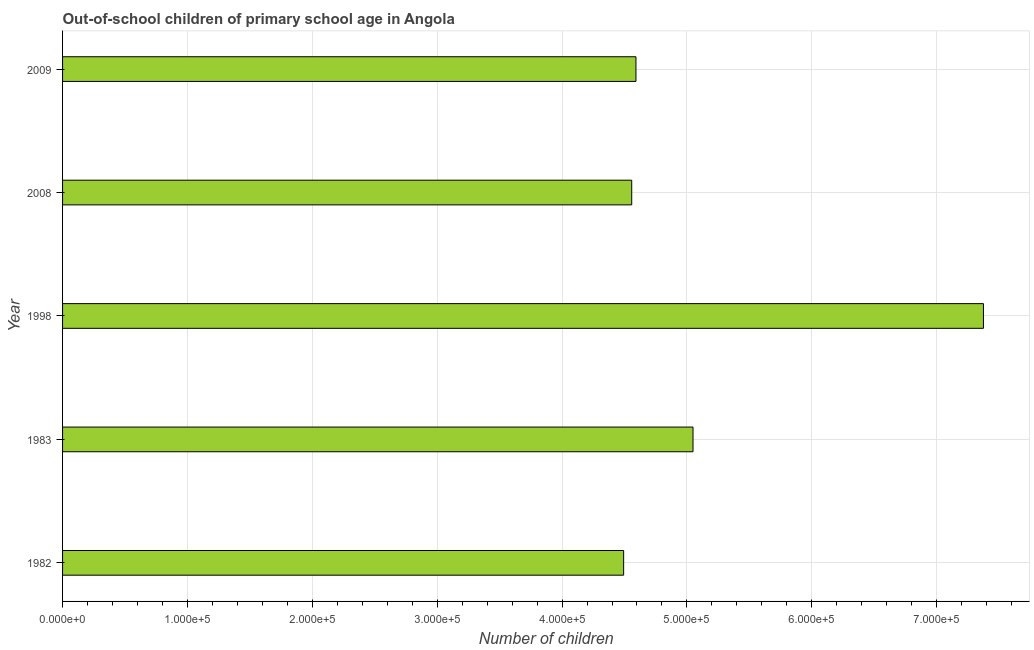Does the graph contain any zero values?
Make the answer very short. No. What is the title of the graph?
Your response must be concise. Out-of-school children of primary school age in Angola. What is the label or title of the X-axis?
Offer a terse response. Number of children. What is the number of out-of-school children in 2008?
Your answer should be very brief. 4.56e+05. Across all years, what is the maximum number of out-of-school children?
Ensure brevity in your answer.  7.37e+05. Across all years, what is the minimum number of out-of-school children?
Make the answer very short. 4.49e+05. In which year was the number of out-of-school children maximum?
Offer a very short reply. 1998. In which year was the number of out-of-school children minimum?
Give a very brief answer. 1982. What is the sum of the number of out-of-school children?
Your response must be concise. 2.61e+06. What is the difference between the number of out-of-school children in 1982 and 2009?
Provide a succinct answer. -9857. What is the average number of out-of-school children per year?
Give a very brief answer. 5.21e+05. What is the median number of out-of-school children?
Give a very brief answer. 4.59e+05. In how many years, is the number of out-of-school children greater than 660000 ?
Your answer should be compact. 1. Do a majority of the years between 1998 and 1983 (inclusive) have number of out-of-school children greater than 500000 ?
Offer a terse response. No. What is the ratio of the number of out-of-school children in 1982 to that in 2009?
Keep it short and to the point. 0.98. Is the difference between the number of out-of-school children in 1982 and 1998 greater than the difference between any two years?
Make the answer very short. Yes. What is the difference between the highest and the second highest number of out-of-school children?
Offer a very short reply. 2.33e+05. What is the difference between the highest and the lowest number of out-of-school children?
Keep it short and to the point. 2.88e+05. How many bars are there?
Keep it short and to the point. 5. What is the difference between two consecutive major ticks on the X-axis?
Provide a short and direct response. 1.00e+05. What is the Number of children in 1982?
Make the answer very short. 4.49e+05. What is the Number of children of 1983?
Give a very brief answer. 5.05e+05. What is the Number of children in 1998?
Your answer should be very brief. 7.37e+05. What is the Number of children of 2008?
Provide a succinct answer. 4.56e+05. What is the Number of children in 2009?
Your answer should be compact. 4.59e+05. What is the difference between the Number of children in 1982 and 1983?
Your answer should be compact. -5.56e+04. What is the difference between the Number of children in 1982 and 1998?
Keep it short and to the point. -2.88e+05. What is the difference between the Number of children in 1982 and 2008?
Your response must be concise. -6469. What is the difference between the Number of children in 1982 and 2009?
Keep it short and to the point. -9857. What is the difference between the Number of children in 1983 and 1998?
Your response must be concise. -2.33e+05. What is the difference between the Number of children in 1983 and 2008?
Give a very brief answer. 4.91e+04. What is the difference between the Number of children in 1983 and 2009?
Provide a short and direct response. 4.57e+04. What is the difference between the Number of children in 1998 and 2008?
Make the answer very short. 2.82e+05. What is the difference between the Number of children in 1998 and 2009?
Your response must be concise. 2.78e+05. What is the difference between the Number of children in 2008 and 2009?
Your answer should be compact. -3388. What is the ratio of the Number of children in 1982 to that in 1983?
Keep it short and to the point. 0.89. What is the ratio of the Number of children in 1982 to that in 1998?
Your response must be concise. 0.61. What is the ratio of the Number of children in 1983 to that in 1998?
Your answer should be compact. 0.69. What is the ratio of the Number of children in 1983 to that in 2008?
Your answer should be compact. 1.11. What is the ratio of the Number of children in 1983 to that in 2009?
Offer a terse response. 1.1. What is the ratio of the Number of children in 1998 to that in 2008?
Make the answer very short. 1.62. What is the ratio of the Number of children in 1998 to that in 2009?
Give a very brief answer. 1.61. 